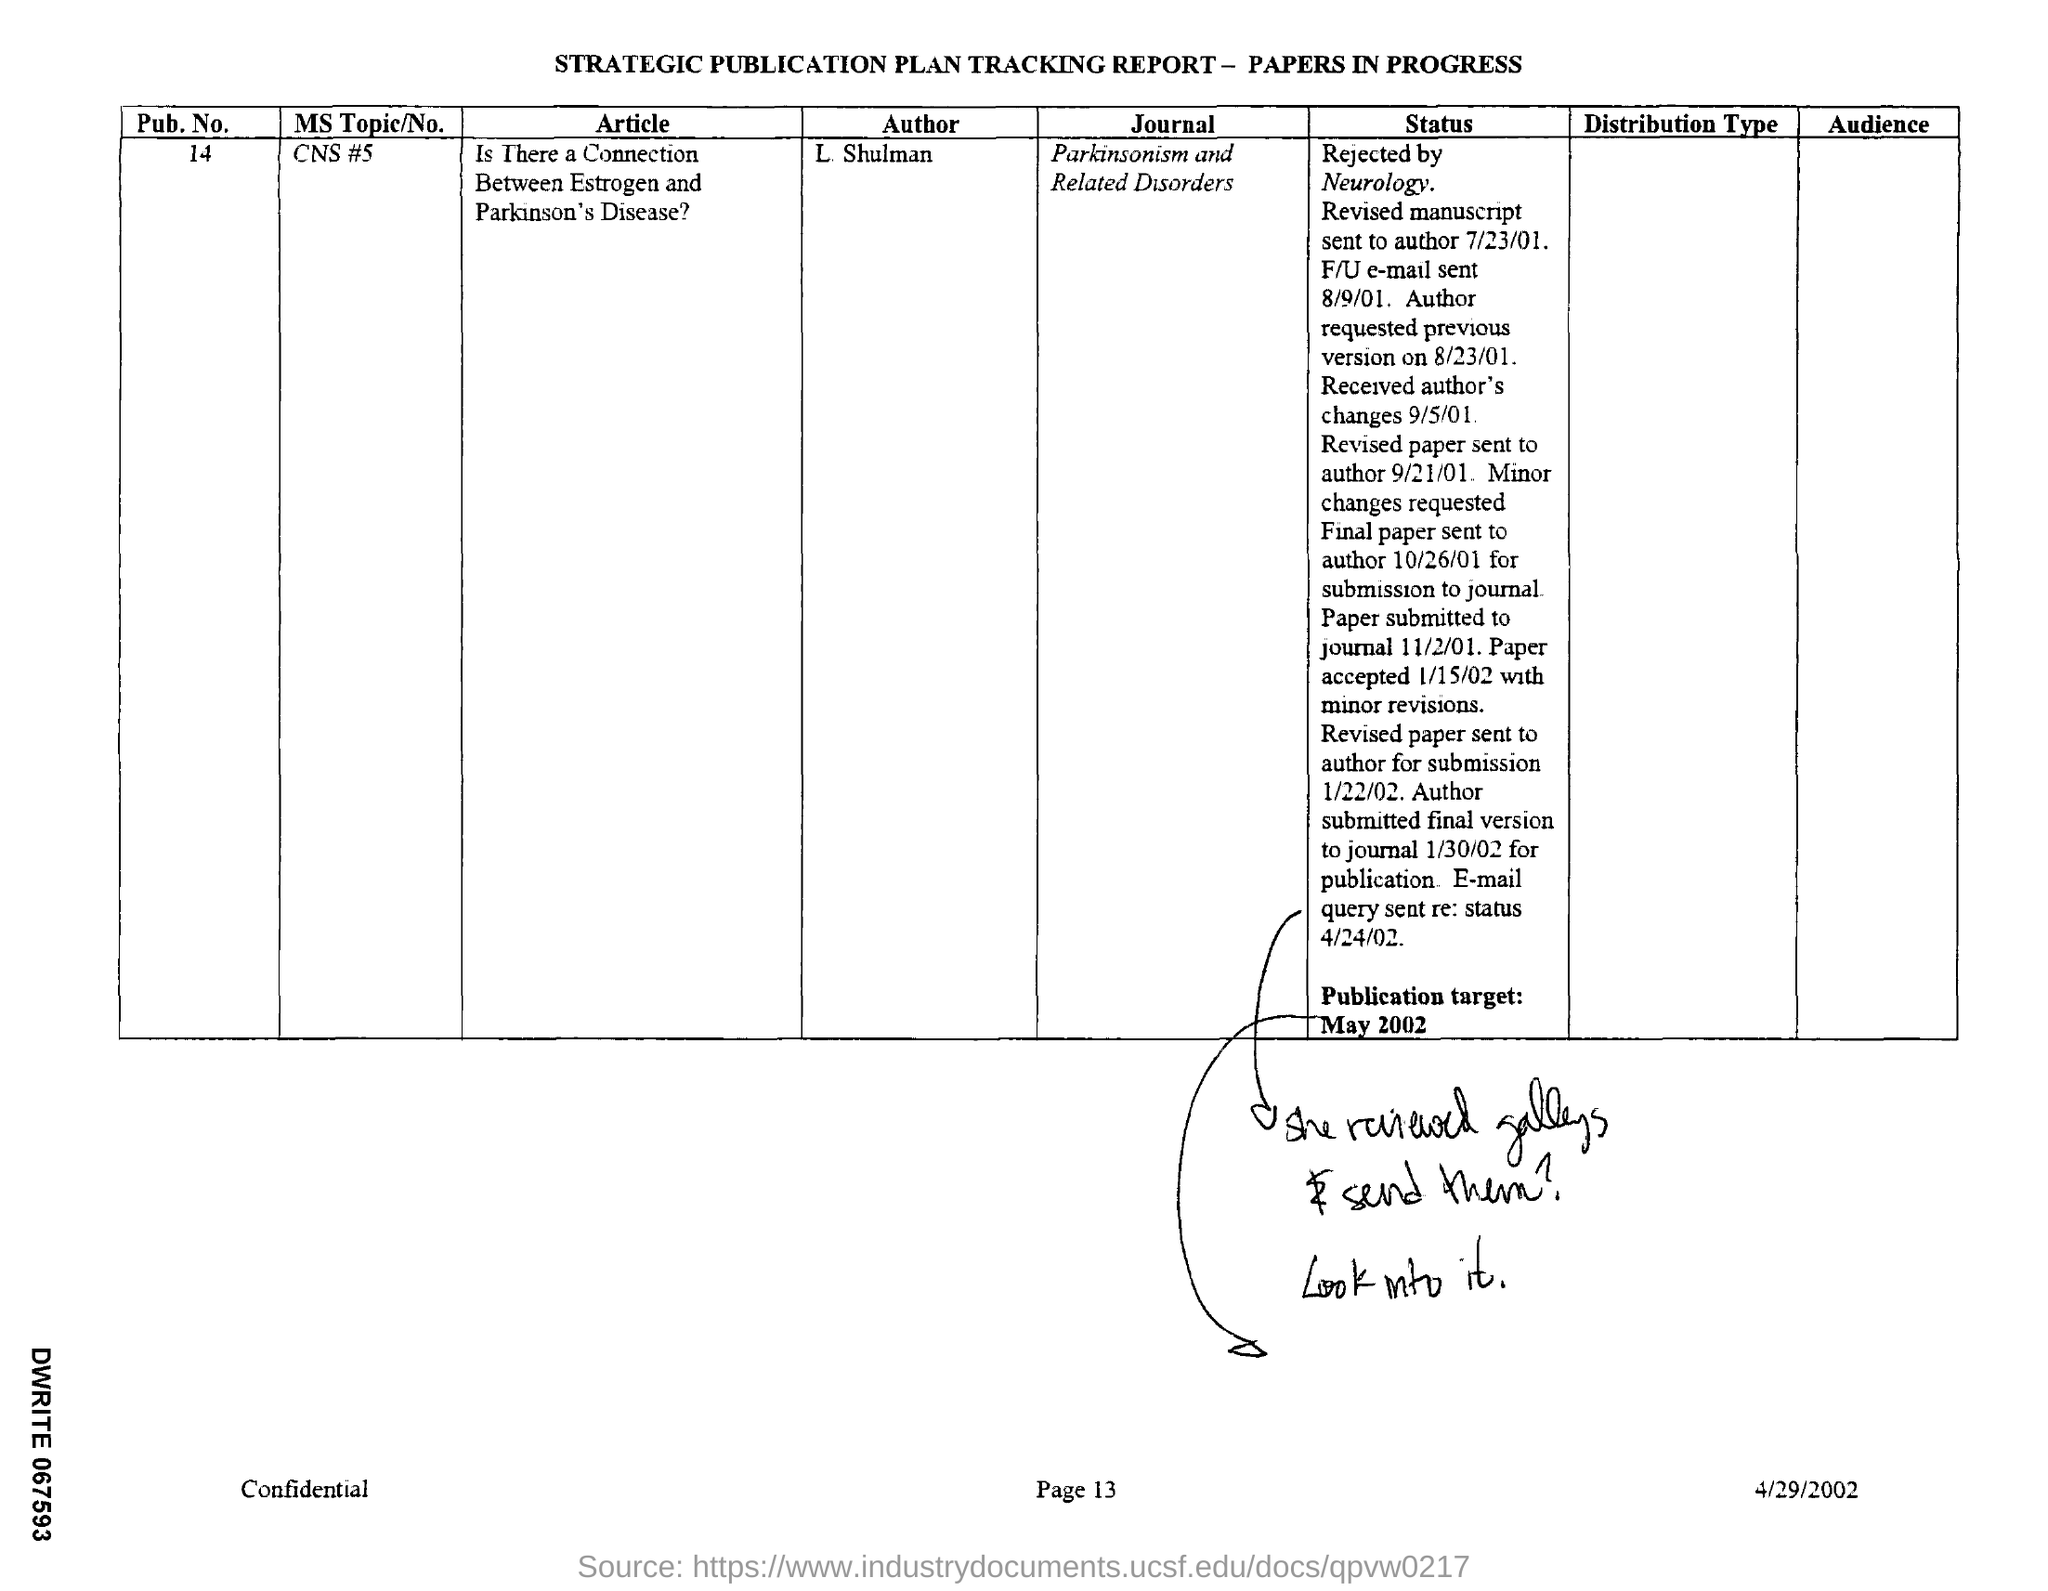What is the document title?
Provide a short and direct response. STRATEGIC PUBLICATION PLAN TRACKING REPORT - PAPERS IN PROGRESS. What is the Pub. No.?
Provide a short and direct response. 14. What is the MS Topic/No.?
Keep it short and to the point. CNS #5. What is the name of the article?
Your answer should be very brief. Is There a Connection Between Estrogen and Parkinson's Disease?. Who is the author?
Offer a very short reply. L Shulman. When is the document dated?
Keep it short and to the point. 4/29/2002. In which Journal is the paper going to published?
Ensure brevity in your answer.  Parkinsonism and Related Disorders. 